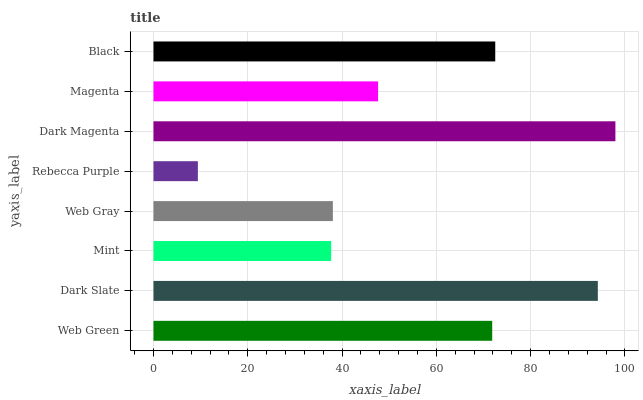Is Rebecca Purple the minimum?
Answer yes or no. Yes. Is Dark Magenta the maximum?
Answer yes or no. Yes. Is Dark Slate the minimum?
Answer yes or no. No. Is Dark Slate the maximum?
Answer yes or no. No. Is Dark Slate greater than Web Green?
Answer yes or no. Yes. Is Web Green less than Dark Slate?
Answer yes or no. Yes. Is Web Green greater than Dark Slate?
Answer yes or no. No. Is Dark Slate less than Web Green?
Answer yes or no. No. Is Web Green the high median?
Answer yes or no. Yes. Is Magenta the low median?
Answer yes or no. Yes. Is Web Gray the high median?
Answer yes or no. No. Is Web Green the low median?
Answer yes or no. No. 